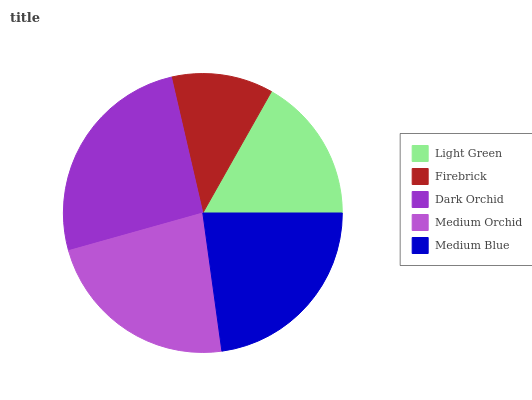Is Firebrick the minimum?
Answer yes or no. Yes. Is Dark Orchid the maximum?
Answer yes or no. Yes. Is Dark Orchid the minimum?
Answer yes or no. No. Is Firebrick the maximum?
Answer yes or no. No. Is Dark Orchid greater than Firebrick?
Answer yes or no. Yes. Is Firebrick less than Dark Orchid?
Answer yes or no. Yes. Is Firebrick greater than Dark Orchid?
Answer yes or no. No. Is Dark Orchid less than Firebrick?
Answer yes or no. No. Is Medium Blue the high median?
Answer yes or no. Yes. Is Medium Blue the low median?
Answer yes or no. Yes. Is Dark Orchid the high median?
Answer yes or no. No. Is Dark Orchid the low median?
Answer yes or no. No. 